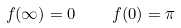<formula> <loc_0><loc_0><loc_500><loc_500>f ( \infty ) = 0 \quad f ( 0 ) = \pi</formula> 